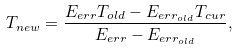Convert formula to latex. <formula><loc_0><loc_0><loc_500><loc_500>T _ { n e w } = \frac { E _ { e r r } T _ { o l d } - E _ { e r r _ { o l d } } T _ { c u r } } { E _ { e r r } - E _ { e r r _ { o l d } } } ,</formula> 